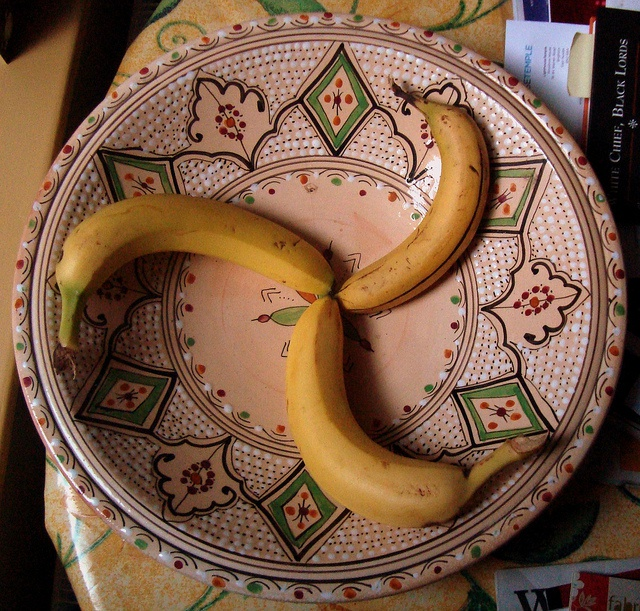Describe the objects in this image and their specific colors. I can see bowl in black, gray, maroon, and tan tones, dining table in black, gray, maroon, and tan tones, banana in black, olive, orange, and maroon tones, banana in black, olive, maroon, and orange tones, and banana in black, red, orange, and maroon tones in this image. 